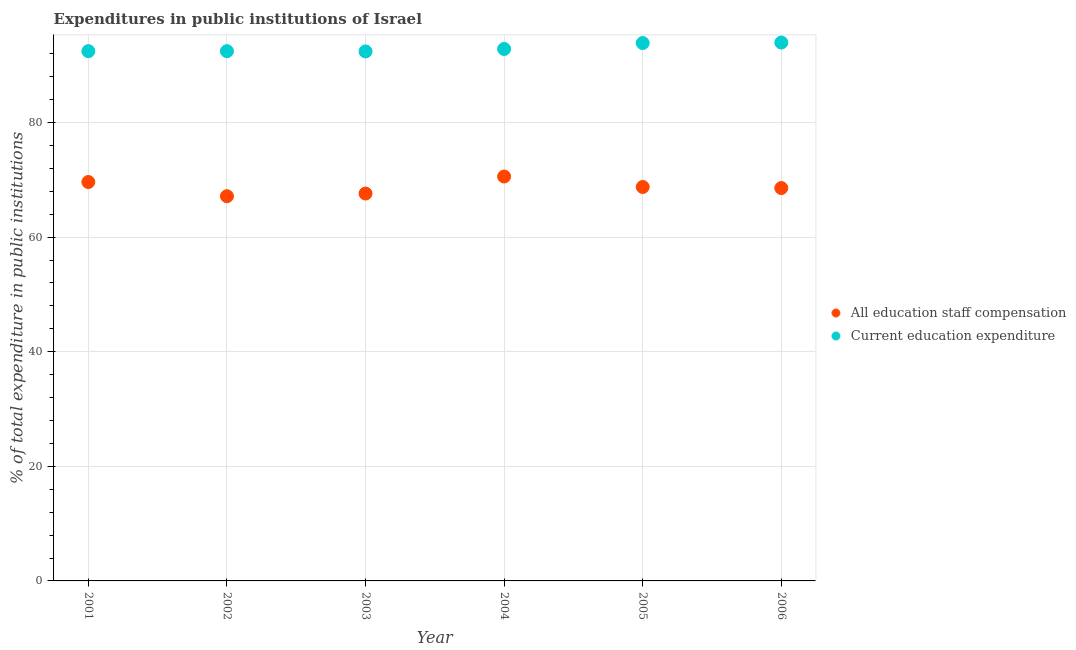What is the expenditure in education in 2003?
Give a very brief answer. 92.41. Across all years, what is the maximum expenditure in staff compensation?
Ensure brevity in your answer.  70.58. Across all years, what is the minimum expenditure in staff compensation?
Provide a succinct answer. 67.14. In which year was the expenditure in education maximum?
Offer a terse response. 2006. In which year was the expenditure in staff compensation minimum?
Ensure brevity in your answer.  2002. What is the total expenditure in education in the graph?
Provide a succinct answer. 557.97. What is the difference between the expenditure in education in 2001 and that in 2005?
Give a very brief answer. -1.41. What is the difference between the expenditure in education in 2006 and the expenditure in staff compensation in 2004?
Your answer should be very brief. 23.38. What is the average expenditure in education per year?
Provide a short and direct response. 93. In the year 2003, what is the difference between the expenditure in staff compensation and expenditure in education?
Make the answer very short. -24.8. What is the ratio of the expenditure in staff compensation in 2001 to that in 2002?
Offer a terse response. 1.04. Is the expenditure in education in 2002 less than that in 2003?
Your answer should be very brief. No. What is the difference between the highest and the second highest expenditure in staff compensation?
Provide a short and direct response. 0.96. What is the difference between the highest and the lowest expenditure in staff compensation?
Make the answer very short. 3.44. In how many years, is the expenditure in staff compensation greater than the average expenditure in staff compensation taken over all years?
Provide a short and direct response. 3. Does the expenditure in staff compensation monotonically increase over the years?
Give a very brief answer. No. Is the expenditure in education strictly less than the expenditure in staff compensation over the years?
Make the answer very short. No. How many years are there in the graph?
Give a very brief answer. 6. Does the graph contain any zero values?
Your response must be concise. No. Where does the legend appear in the graph?
Provide a short and direct response. Center right. How many legend labels are there?
Ensure brevity in your answer.  2. How are the legend labels stacked?
Your response must be concise. Vertical. What is the title of the graph?
Provide a succinct answer. Expenditures in public institutions of Israel. What is the label or title of the Y-axis?
Give a very brief answer. % of total expenditure in public institutions. What is the % of total expenditure in public institutions of All education staff compensation in 2001?
Your response must be concise. 69.62. What is the % of total expenditure in public institutions of Current education expenditure in 2001?
Offer a very short reply. 92.45. What is the % of total expenditure in public institutions of All education staff compensation in 2002?
Give a very brief answer. 67.14. What is the % of total expenditure in public institutions of Current education expenditure in 2002?
Offer a very short reply. 92.45. What is the % of total expenditure in public institutions in All education staff compensation in 2003?
Make the answer very short. 67.61. What is the % of total expenditure in public institutions of Current education expenditure in 2003?
Offer a terse response. 92.41. What is the % of total expenditure in public institutions in All education staff compensation in 2004?
Give a very brief answer. 70.58. What is the % of total expenditure in public institutions of Current education expenditure in 2004?
Keep it short and to the point. 92.84. What is the % of total expenditure in public institutions of All education staff compensation in 2005?
Ensure brevity in your answer.  68.75. What is the % of total expenditure in public institutions in Current education expenditure in 2005?
Keep it short and to the point. 93.87. What is the % of total expenditure in public institutions in All education staff compensation in 2006?
Offer a terse response. 68.56. What is the % of total expenditure in public institutions in Current education expenditure in 2006?
Your response must be concise. 93.95. Across all years, what is the maximum % of total expenditure in public institutions of All education staff compensation?
Ensure brevity in your answer.  70.58. Across all years, what is the maximum % of total expenditure in public institutions of Current education expenditure?
Keep it short and to the point. 93.95. Across all years, what is the minimum % of total expenditure in public institutions of All education staff compensation?
Offer a terse response. 67.14. Across all years, what is the minimum % of total expenditure in public institutions in Current education expenditure?
Make the answer very short. 92.41. What is the total % of total expenditure in public institutions in All education staff compensation in the graph?
Offer a terse response. 412.25. What is the total % of total expenditure in public institutions of Current education expenditure in the graph?
Provide a succinct answer. 557.97. What is the difference between the % of total expenditure in public institutions in All education staff compensation in 2001 and that in 2002?
Keep it short and to the point. 2.48. What is the difference between the % of total expenditure in public institutions in Current education expenditure in 2001 and that in 2002?
Offer a terse response. 0. What is the difference between the % of total expenditure in public institutions in All education staff compensation in 2001 and that in 2003?
Your answer should be very brief. 2.01. What is the difference between the % of total expenditure in public institutions in Current education expenditure in 2001 and that in 2003?
Your response must be concise. 0.05. What is the difference between the % of total expenditure in public institutions of All education staff compensation in 2001 and that in 2004?
Offer a very short reply. -0.96. What is the difference between the % of total expenditure in public institutions in Current education expenditure in 2001 and that in 2004?
Provide a succinct answer. -0.38. What is the difference between the % of total expenditure in public institutions of All education staff compensation in 2001 and that in 2005?
Make the answer very short. 0.87. What is the difference between the % of total expenditure in public institutions of Current education expenditure in 2001 and that in 2005?
Provide a short and direct response. -1.41. What is the difference between the % of total expenditure in public institutions in All education staff compensation in 2001 and that in 2006?
Provide a succinct answer. 1.06. What is the difference between the % of total expenditure in public institutions in Current education expenditure in 2001 and that in 2006?
Ensure brevity in your answer.  -1.5. What is the difference between the % of total expenditure in public institutions in All education staff compensation in 2002 and that in 2003?
Your answer should be compact. -0.47. What is the difference between the % of total expenditure in public institutions of Current education expenditure in 2002 and that in 2003?
Offer a very short reply. 0.05. What is the difference between the % of total expenditure in public institutions in All education staff compensation in 2002 and that in 2004?
Offer a very short reply. -3.44. What is the difference between the % of total expenditure in public institutions of Current education expenditure in 2002 and that in 2004?
Ensure brevity in your answer.  -0.38. What is the difference between the % of total expenditure in public institutions of All education staff compensation in 2002 and that in 2005?
Your answer should be very brief. -1.61. What is the difference between the % of total expenditure in public institutions in Current education expenditure in 2002 and that in 2005?
Your answer should be compact. -1.41. What is the difference between the % of total expenditure in public institutions in All education staff compensation in 2002 and that in 2006?
Keep it short and to the point. -1.42. What is the difference between the % of total expenditure in public institutions of Current education expenditure in 2002 and that in 2006?
Provide a succinct answer. -1.5. What is the difference between the % of total expenditure in public institutions in All education staff compensation in 2003 and that in 2004?
Ensure brevity in your answer.  -2.97. What is the difference between the % of total expenditure in public institutions in Current education expenditure in 2003 and that in 2004?
Your response must be concise. -0.43. What is the difference between the % of total expenditure in public institutions in All education staff compensation in 2003 and that in 2005?
Provide a succinct answer. -1.14. What is the difference between the % of total expenditure in public institutions of Current education expenditure in 2003 and that in 2005?
Offer a very short reply. -1.46. What is the difference between the % of total expenditure in public institutions of All education staff compensation in 2003 and that in 2006?
Your response must be concise. -0.95. What is the difference between the % of total expenditure in public institutions of Current education expenditure in 2003 and that in 2006?
Keep it short and to the point. -1.55. What is the difference between the % of total expenditure in public institutions in All education staff compensation in 2004 and that in 2005?
Offer a very short reply. 1.83. What is the difference between the % of total expenditure in public institutions of Current education expenditure in 2004 and that in 2005?
Make the answer very short. -1.03. What is the difference between the % of total expenditure in public institutions in All education staff compensation in 2004 and that in 2006?
Provide a short and direct response. 2.02. What is the difference between the % of total expenditure in public institutions of Current education expenditure in 2004 and that in 2006?
Your answer should be very brief. -1.12. What is the difference between the % of total expenditure in public institutions in All education staff compensation in 2005 and that in 2006?
Make the answer very short. 0.19. What is the difference between the % of total expenditure in public institutions in Current education expenditure in 2005 and that in 2006?
Your answer should be very brief. -0.09. What is the difference between the % of total expenditure in public institutions in All education staff compensation in 2001 and the % of total expenditure in public institutions in Current education expenditure in 2002?
Your answer should be compact. -22.84. What is the difference between the % of total expenditure in public institutions in All education staff compensation in 2001 and the % of total expenditure in public institutions in Current education expenditure in 2003?
Make the answer very short. -22.79. What is the difference between the % of total expenditure in public institutions of All education staff compensation in 2001 and the % of total expenditure in public institutions of Current education expenditure in 2004?
Give a very brief answer. -23.22. What is the difference between the % of total expenditure in public institutions of All education staff compensation in 2001 and the % of total expenditure in public institutions of Current education expenditure in 2005?
Keep it short and to the point. -24.25. What is the difference between the % of total expenditure in public institutions in All education staff compensation in 2001 and the % of total expenditure in public institutions in Current education expenditure in 2006?
Offer a very short reply. -24.34. What is the difference between the % of total expenditure in public institutions in All education staff compensation in 2002 and the % of total expenditure in public institutions in Current education expenditure in 2003?
Your response must be concise. -25.27. What is the difference between the % of total expenditure in public institutions of All education staff compensation in 2002 and the % of total expenditure in public institutions of Current education expenditure in 2004?
Provide a succinct answer. -25.7. What is the difference between the % of total expenditure in public institutions in All education staff compensation in 2002 and the % of total expenditure in public institutions in Current education expenditure in 2005?
Make the answer very short. -26.73. What is the difference between the % of total expenditure in public institutions of All education staff compensation in 2002 and the % of total expenditure in public institutions of Current education expenditure in 2006?
Provide a short and direct response. -26.82. What is the difference between the % of total expenditure in public institutions of All education staff compensation in 2003 and the % of total expenditure in public institutions of Current education expenditure in 2004?
Offer a terse response. -25.23. What is the difference between the % of total expenditure in public institutions in All education staff compensation in 2003 and the % of total expenditure in public institutions in Current education expenditure in 2005?
Your answer should be compact. -26.26. What is the difference between the % of total expenditure in public institutions in All education staff compensation in 2003 and the % of total expenditure in public institutions in Current education expenditure in 2006?
Your answer should be very brief. -26.35. What is the difference between the % of total expenditure in public institutions of All education staff compensation in 2004 and the % of total expenditure in public institutions of Current education expenditure in 2005?
Make the answer very short. -23.29. What is the difference between the % of total expenditure in public institutions in All education staff compensation in 2004 and the % of total expenditure in public institutions in Current education expenditure in 2006?
Offer a very short reply. -23.38. What is the difference between the % of total expenditure in public institutions in All education staff compensation in 2005 and the % of total expenditure in public institutions in Current education expenditure in 2006?
Your answer should be very brief. -25.2. What is the average % of total expenditure in public institutions of All education staff compensation per year?
Your answer should be compact. 68.71. What is the average % of total expenditure in public institutions of Current education expenditure per year?
Provide a succinct answer. 93. In the year 2001, what is the difference between the % of total expenditure in public institutions of All education staff compensation and % of total expenditure in public institutions of Current education expenditure?
Keep it short and to the point. -22.84. In the year 2002, what is the difference between the % of total expenditure in public institutions of All education staff compensation and % of total expenditure in public institutions of Current education expenditure?
Give a very brief answer. -25.31. In the year 2003, what is the difference between the % of total expenditure in public institutions in All education staff compensation and % of total expenditure in public institutions in Current education expenditure?
Offer a very short reply. -24.8. In the year 2004, what is the difference between the % of total expenditure in public institutions of All education staff compensation and % of total expenditure in public institutions of Current education expenditure?
Give a very brief answer. -22.26. In the year 2005, what is the difference between the % of total expenditure in public institutions in All education staff compensation and % of total expenditure in public institutions in Current education expenditure?
Provide a short and direct response. -25.12. In the year 2006, what is the difference between the % of total expenditure in public institutions in All education staff compensation and % of total expenditure in public institutions in Current education expenditure?
Provide a succinct answer. -25.39. What is the ratio of the % of total expenditure in public institutions in All education staff compensation in 2001 to that in 2002?
Ensure brevity in your answer.  1.04. What is the ratio of the % of total expenditure in public institutions in Current education expenditure in 2001 to that in 2002?
Offer a terse response. 1. What is the ratio of the % of total expenditure in public institutions of All education staff compensation in 2001 to that in 2003?
Your response must be concise. 1.03. What is the ratio of the % of total expenditure in public institutions of All education staff compensation in 2001 to that in 2004?
Keep it short and to the point. 0.99. What is the ratio of the % of total expenditure in public institutions of All education staff compensation in 2001 to that in 2005?
Keep it short and to the point. 1.01. What is the ratio of the % of total expenditure in public institutions of Current education expenditure in 2001 to that in 2005?
Offer a very short reply. 0.98. What is the ratio of the % of total expenditure in public institutions of All education staff compensation in 2001 to that in 2006?
Provide a succinct answer. 1.02. What is the ratio of the % of total expenditure in public institutions in Current education expenditure in 2001 to that in 2006?
Your answer should be compact. 0.98. What is the ratio of the % of total expenditure in public institutions of Current education expenditure in 2002 to that in 2003?
Ensure brevity in your answer.  1. What is the ratio of the % of total expenditure in public institutions of All education staff compensation in 2002 to that in 2004?
Offer a very short reply. 0.95. What is the ratio of the % of total expenditure in public institutions of Current education expenditure in 2002 to that in 2004?
Provide a short and direct response. 1. What is the ratio of the % of total expenditure in public institutions of All education staff compensation in 2002 to that in 2005?
Keep it short and to the point. 0.98. What is the ratio of the % of total expenditure in public institutions of Current education expenditure in 2002 to that in 2005?
Give a very brief answer. 0.98. What is the ratio of the % of total expenditure in public institutions of All education staff compensation in 2002 to that in 2006?
Give a very brief answer. 0.98. What is the ratio of the % of total expenditure in public institutions of All education staff compensation in 2003 to that in 2004?
Provide a short and direct response. 0.96. What is the ratio of the % of total expenditure in public institutions of All education staff compensation in 2003 to that in 2005?
Provide a succinct answer. 0.98. What is the ratio of the % of total expenditure in public institutions in Current education expenditure in 2003 to that in 2005?
Provide a succinct answer. 0.98. What is the ratio of the % of total expenditure in public institutions of All education staff compensation in 2003 to that in 2006?
Ensure brevity in your answer.  0.99. What is the ratio of the % of total expenditure in public institutions in Current education expenditure in 2003 to that in 2006?
Offer a very short reply. 0.98. What is the ratio of the % of total expenditure in public institutions of All education staff compensation in 2004 to that in 2005?
Provide a succinct answer. 1.03. What is the ratio of the % of total expenditure in public institutions of All education staff compensation in 2004 to that in 2006?
Keep it short and to the point. 1.03. What is the ratio of the % of total expenditure in public institutions of Current education expenditure in 2004 to that in 2006?
Provide a succinct answer. 0.99. What is the ratio of the % of total expenditure in public institutions of Current education expenditure in 2005 to that in 2006?
Your answer should be very brief. 1. What is the difference between the highest and the second highest % of total expenditure in public institutions of Current education expenditure?
Your answer should be very brief. 0.09. What is the difference between the highest and the lowest % of total expenditure in public institutions in All education staff compensation?
Make the answer very short. 3.44. What is the difference between the highest and the lowest % of total expenditure in public institutions in Current education expenditure?
Provide a succinct answer. 1.55. 